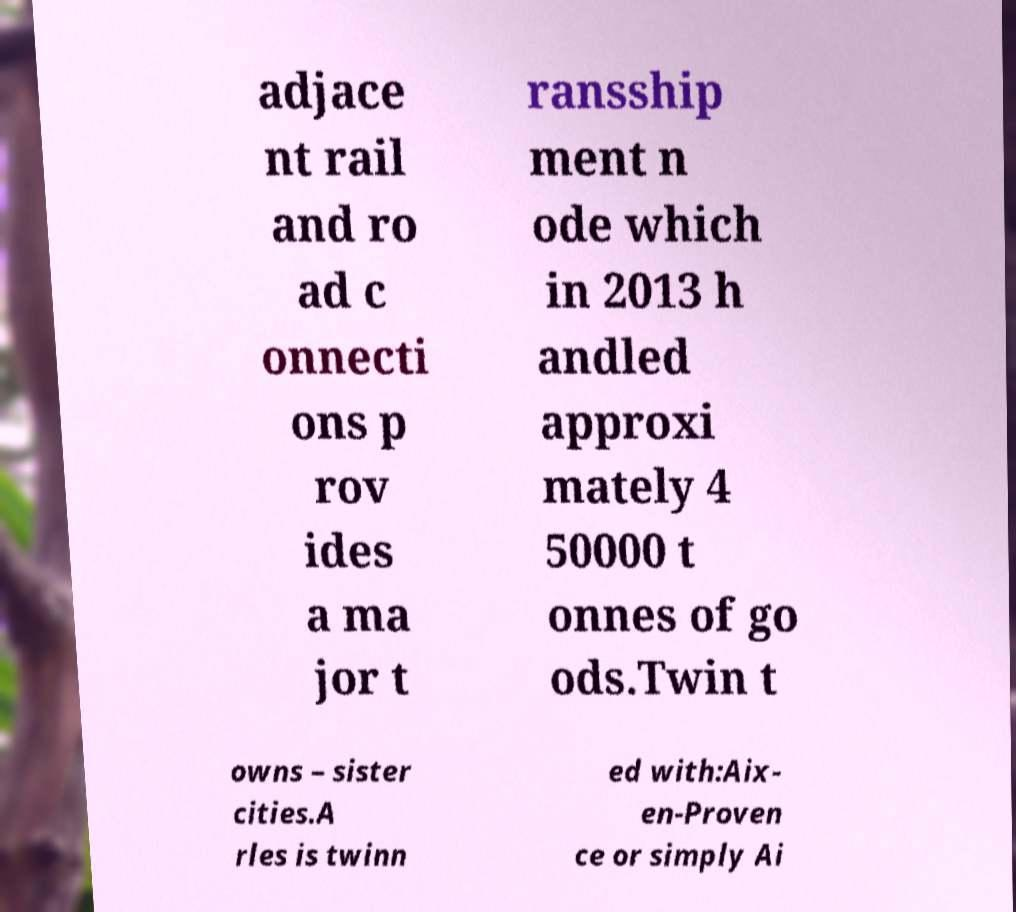Can you accurately transcribe the text from the provided image for me? adjace nt rail and ro ad c onnecti ons p rov ides a ma jor t ransship ment n ode which in 2013 h andled approxi mately 4 50000 t onnes of go ods.Twin t owns – sister cities.A rles is twinn ed with:Aix- en-Proven ce or simply Ai 